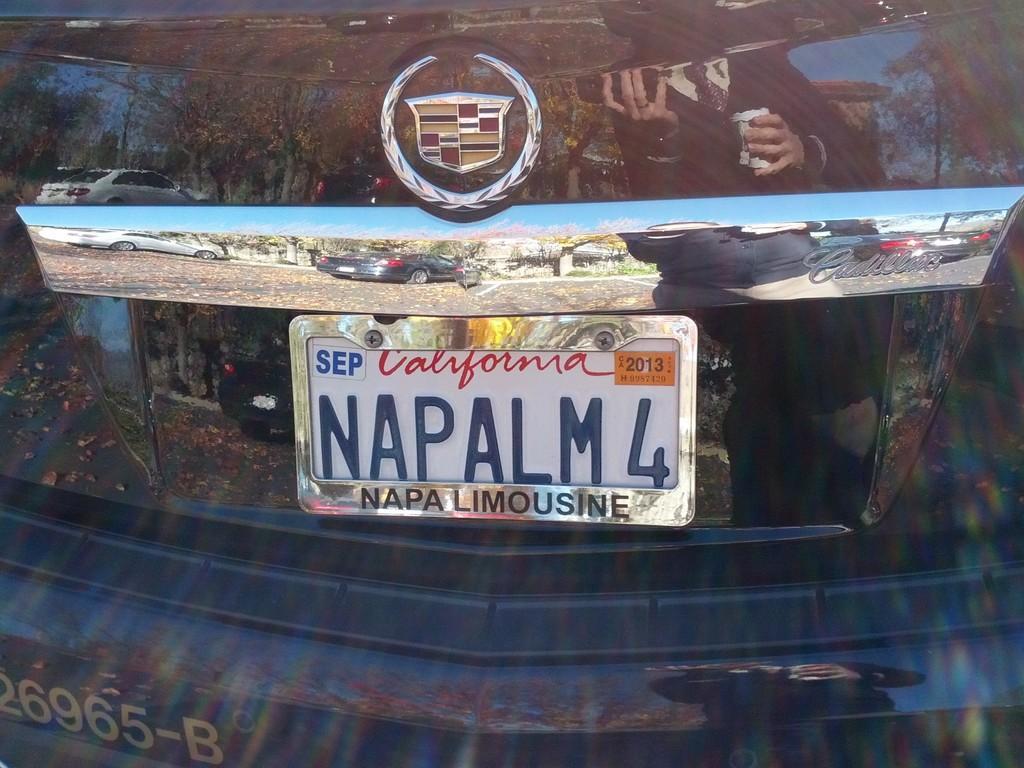Describe this image in one or two sentences. In this picture, we see a car in blue color. In the middle of the picture, we see a number plate in white color. At the top, we see the logo of the car. We even see the cars, trees and a building in this picture. 